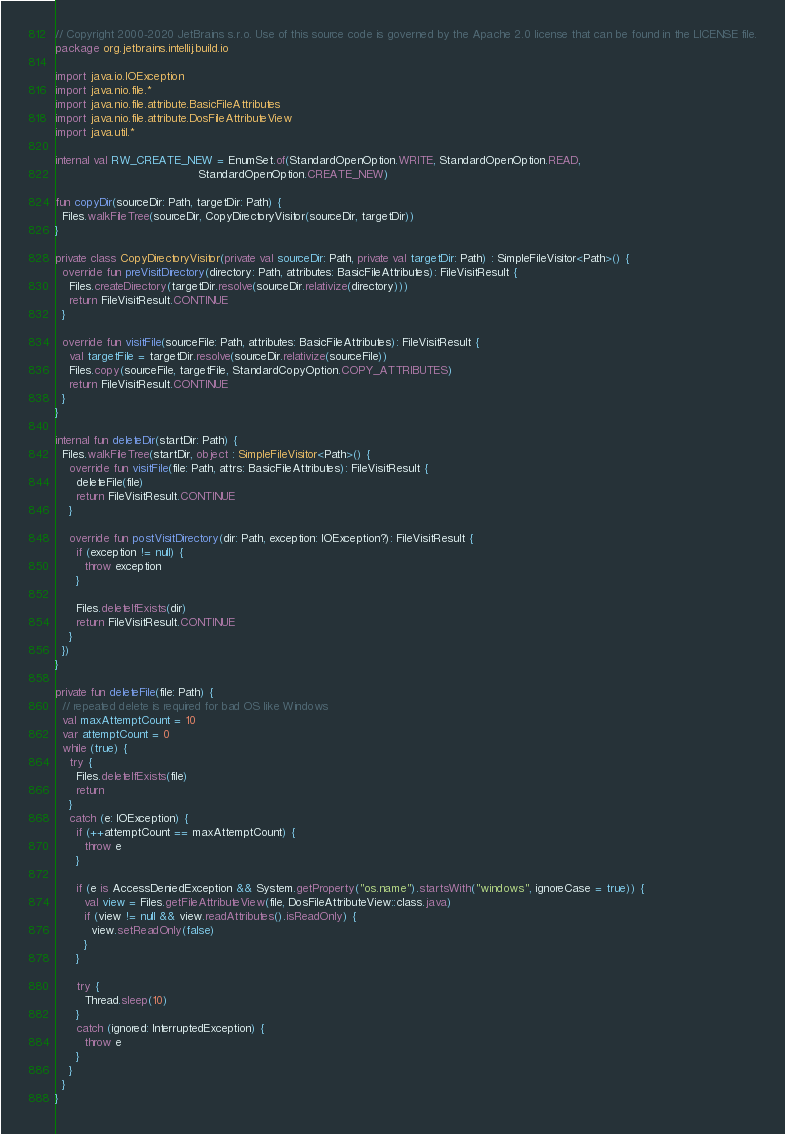<code> <loc_0><loc_0><loc_500><loc_500><_Kotlin_>// Copyright 2000-2020 JetBrains s.r.o. Use of this source code is governed by the Apache 2.0 license that can be found in the LICENSE file.
package org.jetbrains.intellij.build.io

import java.io.IOException
import java.nio.file.*
import java.nio.file.attribute.BasicFileAttributes
import java.nio.file.attribute.DosFileAttributeView
import java.util.*

internal val RW_CREATE_NEW = EnumSet.of(StandardOpenOption.WRITE, StandardOpenOption.READ,
                                        StandardOpenOption.CREATE_NEW)

fun copyDir(sourceDir: Path, targetDir: Path) {
  Files.walkFileTree(sourceDir, CopyDirectoryVisitor(sourceDir, targetDir))
}

private class CopyDirectoryVisitor(private val sourceDir: Path, private val targetDir: Path) : SimpleFileVisitor<Path>() {
  override fun preVisitDirectory(directory: Path, attributes: BasicFileAttributes): FileVisitResult {
    Files.createDirectory(targetDir.resolve(sourceDir.relativize(directory)))
    return FileVisitResult.CONTINUE
  }

  override fun visitFile(sourceFile: Path, attributes: BasicFileAttributes): FileVisitResult {
    val targetFile = targetDir.resolve(sourceDir.relativize(sourceFile))
    Files.copy(sourceFile, targetFile, StandardCopyOption.COPY_ATTRIBUTES)
    return FileVisitResult.CONTINUE
  }
}

internal fun deleteDir(startDir: Path) {
  Files.walkFileTree(startDir, object : SimpleFileVisitor<Path>() {
    override fun visitFile(file: Path, attrs: BasicFileAttributes): FileVisitResult {
      deleteFile(file)
      return FileVisitResult.CONTINUE
    }

    override fun postVisitDirectory(dir: Path, exception: IOException?): FileVisitResult {
      if (exception != null) {
        throw exception
      }

      Files.deleteIfExists(dir)
      return FileVisitResult.CONTINUE
    }
  })
}

private fun deleteFile(file: Path) {
  // repeated delete is required for bad OS like Windows
  val maxAttemptCount = 10
  var attemptCount = 0
  while (true) {
    try {
      Files.deleteIfExists(file)
      return
    }
    catch (e: IOException) {
      if (++attemptCount == maxAttemptCount) {
        throw e
      }

      if (e is AccessDeniedException && System.getProperty("os.name").startsWith("windows", ignoreCase = true)) {
        val view = Files.getFileAttributeView(file, DosFileAttributeView::class.java)
        if (view != null && view.readAttributes().isReadOnly) {
          view.setReadOnly(false)
        }
      }

      try {
        Thread.sleep(10)
      }
      catch (ignored: InterruptedException) {
        throw e
      }
    }
  }
}</code> 